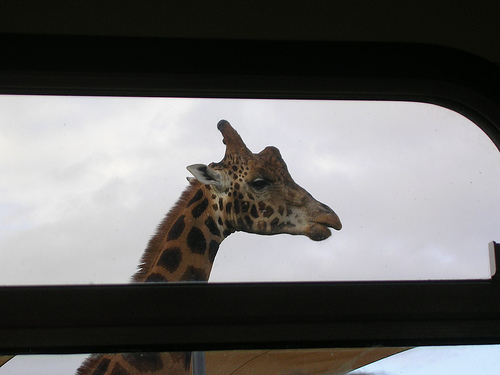<image>
Is there a giraffe behind the window? Yes. From this viewpoint, the giraffe is positioned behind the window, with the window partially or fully occluding the giraffe. 